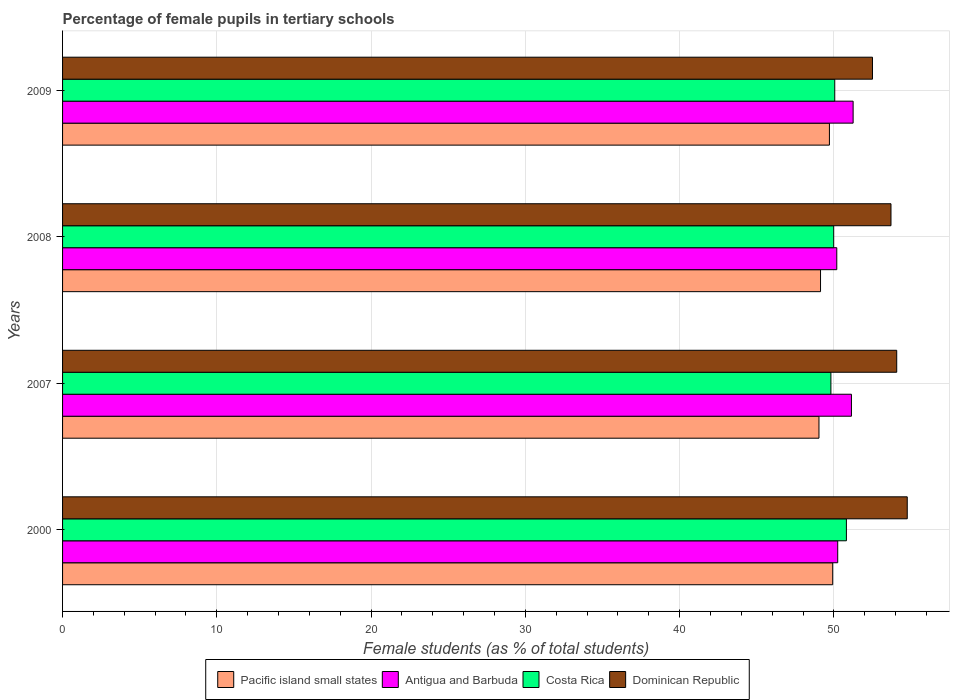How many different coloured bars are there?
Give a very brief answer. 4. Are the number of bars per tick equal to the number of legend labels?
Give a very brief answer. Yes. How many bars are there on the 1st tick from the top?
Your answer should be compact. 4. What is the percentage of female pupils in tertiary schools in Pacific island small states in 2000?
Your response must be concise. 49.92. Across all years, what is the maximum percentage of female pupils in tertiary schools in Dominican Republic?
Your response must be concise. 54.75. Across all years, what is the minimum percentage of female pupils in tertiary schools in Antigua and Barbuda?
Your response must be concise. 50.19. What is the total percentage of female pupils in tertiary schools in Antigua and Barbuda in the graph?
Offer a terse response. 202.81. What is the difference between the percentage of female pupils in tertiary schools in Antigua and Barbuda in 2007 and that in 2008?
Offer a very short reply. 0.95. What is the difference between the percentage of female pupils in tertiary schools in Antigua and Barbuda in 2000 and the percentage of female pupils in tertiary schools in Dominican Republic in 2007?
Provide a short and direct response. -3.82. What is the average percentage of female pupils in tertiary schools in Antigua and Barbuda per year?
Your answer should be compact. 50.7. In the year 2008, what is the difference between the percentage of female pupils in tertiary schools in Costa Rica and percentage of female pupils in tertiary schools in Pacific island small states?
Keep it short and to the point. 0.85. In how many years, is the percentage of female pupils in tertiary schools in Dominican Republic greater than 42 %?
Ensure brevity in your answer.  4. What is the ratio of the percentage of female pupils in tertiary schools in Costa Rica in 2000 to that in 2007?
Make the answer very short. 1.02. Is the difference between the percentage of female pupils in tertiary schools in Costa Rica in 2007 and 2009 greater than the difference between the percentage of female pupils in tertiary schools in Pacific island small states in 2007 and 2009?
Offer a very short reply. Yes. What is the difference between the highest and the second highest percentage of female pupils in tertiary schools in Pacific island small states?
Ensure brevity in your answer.  0.21. What is the difference between the highest and the lowest percentage of female pupils in tertiary schools in Dominican Republic?
Provide a succinct answer. 2.25. In how many years, is the percentage of female pupils in tertiary schools in Antigua and Barbuda greater than the average percentage of female pupils in tertiary schools in Antigua and Barbuda taken over all years?
Provide a short and direct response. 2. Is it the case that in every year, the sum of the percentage of female pupils in tertiary schools in Pacific island small states and percentage of female pupils in tertiary schools in Costa Rica is greater than the sum of percentage of female pupils in tertiary schools in Dominican Republic and percentage of female pupils in tertiary schools in Antigua and Barbuda?
Offer a terse response. Yes. What does the 1st bar from the bottom in 2009 represents?
Give a very brief answer. Pacific island small states. Is it the case that in every year, the sum of the percentage of female pupils in tertiary schools in Dominican Republic and percentage of female pupils in tertiary schools in Pacific island small states is greater than the percentage of female pupils in tertiary schools in Antigua and Barbuda?
Keep it short and to the point. Yes. Are all the bars in the graph horizontal?
Provide a succinct answer. Yes. How many years are there in the graph?
Ensure brevity in your answer.  4. Are the values on the major ticks of X-axis written in scientific E-notation?
Provide a succinct answer. No. Does the graph contain grids?
Ensure brevity in your answer.  Yes. How many legend labels are there?
Ensure brevity in your answer.  4. How are the legend labels stacked?
Provide a short and direct response. Horizontal. What is the title of the graph?
Offer a terse response. Percentage of female pupils in tertiary schools. Does "Togo" appear as one of the legend labels in the graph?
Make the answer very short. No. What is the label or title of the X-axis?
Your answer should be compact. Female students (as % of total students). What is the label or title of the Y-axis?
Give a very brief answer. Years. What is the Female students (as % of total students) in Pacific island small states in 2000?
Provide a succinct answer. 49.92. What is the Female students (as % of total students) of Antigua and Barbuda in 2000?
Offer a terse response. 50.25. What is the Female students (as % of total students) in Costa Rica in 2000?
Give a very brief answer. 50.81. What is the Female students (as % of total students) of Dominican Republic in 2000?
Make the answer very short. 54.75. What is the Female students (as % of total students) in Pacific island small states in 2007?
Keep it short and to the point. 49.03. What is the Female students (as % of total students) in Antigua and Barbuda in 2007?
Offer a terse response. 51.14. What is the Female students (as % of total students) of Costa Rica in 2007?
Offer a terse response. 49.8. What is the Female students (as % of total students) of Dominican Republic in 2007?
Your answer should be very brief. 54.07. What is the Female students (as % of total students) in Pacific island small states in 2008?
Make the answer very short. 49.13. What is the Female students (as % of total students) in Antigua and Barbuda in 2008?
Offer a very short reply. 50.19. What is the Female students (as % of total students) of Costa Rica in 2008?
Make the answer very short. 49.99. What is the Female students (as % of total students) of Dominican Republic in 2008?
Make the answer very short. 53.7. What is the Female students (as % of total students) in Pacific island small states in 2009?
Your response must be concise. 49.71. What is the Female students (as % of total students) of Antigua and Barbuda in 2009?
Ensure brevity in your answer.  51.24. What is the Female students (as % of total students) in Costa Rica in 2009?
Your answer should be compact. 50.05. What is the Female students (as % of total students) of Dominican Republic in 2009?
Your answer should be compact. 52.5. Across all years, what is the maximum Female students (as % of total students) in Pacific island small states?
Offer a terse response. 49.92. Across all years, what is the maximum Female students (as % of total students) of Antigua and Barbuda?
Provide a short and direct response. 51.24. Across all years, what is the maximum Female students (as % of total students) of Costa Rica?
Make the answer very short. 50.81. Across all years, what is the maximum Female students (as % of total students) in Dominican Republic?
Your answer should be very brief. 54.75. Across all years, what is the minimum Female students (as % of total students) of Pacific island small states?
Provide a succinct answer. 49.03. Across all years, what is the minimum Female students (as % of total students) in Antigua and Barbuda?
Make the answer very short. 50.19. Across all years, what is the minimum Female students (as % of total students) in Costa Rica?
Offer a terse response. 49.8. Across all years, what is the minimum Female students (as % of total students) of Dominican Republic?
Ensure brevity in your answer.  52.5. What is the total Female students (as % of total students) in Pacific island small states in the graph?
Give a very brief answer. 197.79. What is the total Female students (as % of total students) in Antigua and Barbuda in the graph?
Offer a very short reply. 202.81. What is the total Female students (as % of total students) in Costa Rica in the graph?
Provide a short and direct response. 200.65. What is the total Female students (as % of total students) in Dominican Republic in the graph?
Your response must be concise. 215.02. What is the difference between the Female students (as % of total students) in Pacific island small states in 2000 and that in 2007?
Give a very brief answer. 0.89. What is the difference between the Female students (as % of total students) of Antigua and Barbuda in 2000 and that in 2007?
Ensure brevity in your answer.  -0.89. What is the difference between the Female students (as % of total students) in Dominican Republic in 2000 and that in 2007?
Your response must be concise. 0.68. What is the difference between the Female students (as % of total students) in Pacific island small states in 2000 and that in 2008?
Your answer should be compact. 0.79. What is the difference between the Female students (as % of total students) in Antigua and Barbuda in 2000 and that in 2008?
Provide a short and direct response. 0.06. What is the difference between the Female students (as % of total students) of Costa Rica in 2000 and that in 2008?
Provide a short and direct response. 0.82. What is the difference between the Female students (as % of total students) in Dominican Republic in 2000 and that in 2008?
Ensure brevity in your answer.  1.05. What is the difference between the Female students (as % of total students) of Pacific island small states in 2000 and that in 2009?
Ensure brevity in your answer.  0.21. What is the difference between the Female students (as % of total students) of Antigua and Barbuda in 2000 and that in 2009?
Ensure brevity in your answer.  -1. What is the difference between the Female students (as % of total students) in Costa Rica in 2000 and that in 2009?
Your response must be concise. 0.75. What is the difference between the Female students (as % of total students) in Dominican Republic in 2000 and that in 2009?
Your answer should be very brief. 2.25. What is the difference between the Female students (as % of total students) of Pacific island small states in 2007 and that in 2008?
Your response must be concise. -0.1. What is the difference between the Female students (as % of total students) of Antigua and Barbuda in 2007 and that in 2008?
Make the answer very short. 0.95. What is the difference between the Female students (as % of total students) in Costa Rica in 2007 and that in 2008?
Your answer should be compact. -0.18. What is the difference between the Female students (as % of total students) in Dominican Republic in 2007 and that in 2008?
Provide a short and direct response. 0.37. What is the difference between the Female students (as % of total students) in Pacific island small states in 2007 and that in 2009?
Your answer should be compact. -0.68. What is the difference between the Female students (as % of total students) in Antigua and Barbuda in 2007 and that in 2009?
Give a very brief answer. -0.11. What is the difference between the Female students (as % of total students) in Costa Rica in 2007 and that in 2009?
Your answer should be very brief. -0.25. What is the difference between the Female students (as % of total students) of Dominican Republic in 2007 and that in 2009?
Provide a short and direct response. 1.57. What is the difference between the Female students (as % of total students) in Pacific island small states in 2008 and that in 2009?
Provide a short and direct response. -0.58. What is the difference between the Female students (as % of total students) of Antigua and Barbuda in 2008 and that in 2009?
Give a very brief answer. -1.06. What is the difference between the Female students (as % of total students) in Costa Rica in 2008 and that in 2009?
Keep it short and to the point. -0.07. What is the difference between the Female students (as % of total students) in Dominican Republic in 2008 and that in 2009?
Provide a succinct answer. 1.2. What is the difference between the Female students (as % of total students) of Pacific island small states in 2000 and the Female students (as % of total students) of Antigua and Barbuda in 2007?
Your response must be concise. -1.21. What is the difference between the Female students (as % of total students) in Pacific island small states in 2000 and the Female students (as % of total students) in Costa Rica in 2007?
Offer a terse response. 0.12. What is the difference between the Female students (as % of total students) in Pacific island small states in 2000 and the Female students (as % of total students) in Dominican Republic in 2007?
Keep it short and to the point. -4.15. What is the difference between the Female students (as % of total students) of Antigua and Barbuda in 2000 and the Female students (as % of total students) of Costa Rica in 2007?
Your answer should be very brief. 0.44. What is the difference between the Female students (as % of total students) of Antigua and Barbuda in 2000 and the Female students (as % of total students) of Dominican Republic in 2007?
Offer a very short reply. -3.82. What is the difference between the Female students (as % of total students) in Costa Rica in 2000 and the Female students (as % of total students) in Dominican Republic in 2007?
Offer a very short reply. -3.26. What is the difference between the Female students (as % of total students) of Pacific island small states in 2000 and the Female students (as % of total students) of Antigua and Barbuda in 2008?
Give a very brief answer. -0.26. What is the difference between the Female students (as % of total students) in Pacific island small states in 2000 and the Female students (as % of total students) in Costa Rica in 2008?
Provide a short and direct response. -0.07. What is the difference between the Female students (as % of total students) in Pacific island small states in 2000 and the Female students (as % of total students) in Dominican Republic in 2008?
Offer a terse response. -3.78. What is the difference between the Female students (as % of total students) in Antigua and Barbuda in 2000 and the Female students (as % of total students) in Costa Rica in 2008?
Make the answer very short. 0.26. What is the difference between the Female students (as % of total students) of Antigua and Barbuda in 2000 and the Female students (as % of total students) of Dominican Republic in 2008?
Your answer should be compact. -3.45. What is the difference between the Female students (as % of total students) in Costa Rica in 2000 and the Female students (as % of total students) in Dominican Republic in 2008?
Give a very brief answer. -2.89. What is the difference between the Female students (as % of total students) of Pacific island small states in 2000 and the Female students (as % of total students) of Antigua and Barbuda in 2009?
Keep it short and to the point. -1.32. What is the difference between the Female students (as % of total students) in Pacific island small states in 2000 and the Female students (as % of total students) in Costa Rica in 2009?
Provide a succinct answer. -0.13. What is the difference between the Female students (as % of total students) in Pacific island small states in 2000 and the Female students (as % of total students) in Dominican Republic in 2009?
Keep it short and to the point. -2.58. What is the difference between the Female students (as % of total students) in Antigua and Barbuda in 2000 and the Female students (as % of total students) in Costa Rica in 2009?
Your answer should be very brief. 0.19. What is the difference between the Female students (as % of total students) in Antigua and Barbuda in 2000 and the Female students (as % of total students) in Dominican Republic in 2009?
Make the answer very short. -2.25. What is the difference between the Female students (as % of total students) in Costa Rica in 2000 and the Female students (as % of total students) in Dominican Republic in 2009?
Your response must be concise. -1.69. What is the difference between the Female students (as % of total students) of Pacific island small states in 2007 and the Female students (as % of total students) of Antigua and Barbuda in 2008?
Provide a short and direct response. -1.15. What is the difference between the Female students (as % of total students) of Pacific island small states in 2007 and the Female students (as % of total students) of Costa Rica in 2008?
Your answer should be compact. -0.96. What is the difference between the Female students (as % of total students) of Pacific island small states in 2007 and the Female students (as % of total students) of Dominican Republic in 2008?
Give a very brief answer. -4.67. What is the difference between the Female students (as % of total students) of Antigua and Barbuda in 2007 and the Female students (as % of total students) of Costa Rica in 2008?
Your answer should be very brief. 1.15. What is the difference between the Female students (as % of total students) of Antigua and Barbuda in 2007 and the Female students (as % of total students) of Dominican Republic in 2008?
Your response must be concise. -2.56. What is the difference between the Female students (as % of total students) of Costa Rica in 2007 and the Female students (as % of total students) of Dominican Republic in 2008?
Your answer should be very brief. -3.89. What is the difference between the Female students (as % of total students) of Pacific island small states in 2007 and the Female students (as % of total students) of Antigua and Barbuda in 2009?
Give a very brief answer. -2.21. What is the difference between the Female students (as % of total students) in Pacific island small states in 2007 and the Female students (as % of total students) in Costa Rica in 2009?
Offer a terse response. -1.02. What is the difference between the Female students (as % of total students) of Pacific island small states in 2007 and the Female students (as % of total students) of Dominican Republic in 2009?
Make the answer very short. -3.47. What is the difference between the Female students (as % of total students) in Antigua and Barbuda in 2007 and the Female students (as % of total students) in Costa Rica in 2009?
Give a very brief answer. 1.08. What is the difference between the Female students (as % of total students) in Antigua and Barbuda in 2007 and the Female students (as % of total students) in Dominican Republic in 2009?
Provide a succinct answer. -1.36. What is the difference between the Female students (as % of total students) in Costa Rica in 2007 and the Female students (as % of total students) in Dominican Republic in 2009?
Provide a succinct answer. -2.7. What is the difference between the Female students (as % of total students) of Pacific island small states in 2008 and the Female students (as % of total students) of Antigua and Barbuda in 2009?
Make the answer very short. -2.11. What is the difference between the Female students (as % of total students) of Pacific island small states in 2008 and the Female students (as % of total students) of Costa Rica in 2009?
Offer a very short reply. -0.92. What is the difference between the Female students (as % of total students) in Pacific island small states in 2008 and the Female students (as % of total students) in Dominican Republic in 2009?
Ensure brevity in your answer.  -3.37. What is the difference between the Female students (as % of total students) in Antigua and Barbuda in 2008 and the Female students (as % of total students) in Costa Rica in 2009?
Provide a short and direct response. 0.13. What is the difference between the Female students (as % of total students) in Antigua and Barbuda in 2008 and the Female students (as % of total students) in Dominican Republic in 2009?
Your response must be concise. -2.31. What is the difference between the Female students (as % of total students) in Costa Rica in 2008 and the Female students (as % of total students) in Dominican Republic in 2009?
Keep it short and to the point. -2.51. What is the average Female students (as % of total students) in Pacific island small states per year?
Provide a short and direct response. 49.45. What is the average Female students (as % of total students) of Antigua and Barbuda per year?
Provide a short and direct response. 50.7. What is the average Female students (as % of total students) in Costa Rica per year?
Make the answer very short. 50.16. What is the average Female students (as % of total students) in Dominican Republic per year?
Offer a terse response. 53.76. In the year 2000, what is the difference between the Female students (as % of total students) in Pacific island small states and Female students (as % of total students) in Antigua and Barbuda?
Make the answer very short. -0.33. In the year 2000, what is the difference between the Female students (as % of total students) in Pacific island small states and Female students (as % of total students) in Costa Rica?
Give a very brief answer. -0.89. In the year 2000, what is the difference between the Female students (as % of total students) of Pacific island small states and Female students (as % of total students) of Dominican Republic?
Your answer should be compact. -4.83. In the year 2000, what is the difference between the Female students (as % of total students) of Antigua and Barbuda and Female students (as % of total students) of Costa Rica?
Provide a succinct answer. -0.56. In the year 2000, what is the difference between the Female students (as % of total students) in Antigua and Barbuda and Female students (as % of total students) in Dominican Republic?
Your response must be concise. -4.51. In the year 2000, what is the difference between the Female students (as % of total students) of Costa Rica and Female students (as % of total students) of Dominican Republic?
Your answer should be very brief. -3.94. In the year 2007, what is the difference between the Female students (as % of total students) in Pacific island small states and Female students (as % of total students) in Antigua and Barbuda?
Your response must be concise. -2.1. In the year 2007, what is the difference between the Female students (as % of total students) in Pacific island small states and Female students (as % of total students) in Costa Rica?
Provide a succinct answer. -0.77. In the year 2007, what is the difference between the Female students (as % of total students) of Pacific island small states and Female students (as % of total students) of Dominican Republic?
Provide a succinct answer. -5.04. In the year 2007, what is the difference between the Female students (as % of total students) of Antigua and Barbuda and Female students (as % of total students) of Costa Rica?
Your response must be concise. 1.33. In the year 2007, what is the difference between the Female students (as % of total students) in Antigua and Barbuda and Female students (as % of total students) in Dominican Republic?
Offer a terse response. -2.94. In the year 2007, what is the difference between the Female students (as % of total students) of Costa Rica and Female students (as % of total students) of Dominican Republic?
Provide a short and direct response. -4.27. In the year 2008, what is the difference between the Female students (as % of total students) of Pacific island small states and Female students (as % of total students) of Antigua and Barbuda?
Keep it short and to the point. -1.05. In the year 2008, what is the difference between the Female students (as % of total students) in Pacific island small states and Female students (as % of total students) in Costa Rica?
Offer a terse response. -0.85. In the year 2008, what is the difference between the Female students (as % of total students) of Pacific island small states and Female students (as % of total students) of Dominican Republic?
Offer a terse response. -4.57. In the year 2008, what is the difference between the Female students (as % of total students) of Antigua and Barbuda and Female students (as % of total students) of Costa Rica?
Offer a terse response. 0.2. In the year 2008, what is the difference between the Female students (as % of total students) in Antigua and Barbuda and Female students (as % of total students) in Dominican Republic?
Give a very brief answer. -3.51. In the year 2008, what is the difference between the Female students (as % of total students) in Costa Rica and Female students (as % of total students) in Dominican Republic?
Offer a terse response. -3.71. In the year 2009, what is the difference between the Female students (as % of total students) in Pacific island small states and Female students (as % of total students) in Antigua and Barbuda?
Offer a terse response. -1.54. In the year 2009, what is the difference between the Female students (as % of total students) in Pacific island small states and Female students (as % of total students) in Costa Rica?
Ensure brevity in your answer.  -0.35. In the year 2009, what is the difference between the Female students (as % of total students) of Pacific island small states and Female students (as % of total students) of Dominican Republic?
Offer a very short reply. -2.79. In the year 2009, what is the difference between the Female students (as % of total students) in Antigua and Barbuda and Female students (as % of total students) in Costa Rica?
Offer a very short reply. 1.19. In the year 2009, what is the difference between the Female students (as % of total students) of Antigua and Barbuda and Female students (as % of total students) of Dominican Republic?
Provide a succinct answer. -1.26. In the year 2009, what is the difference between the Female students (as % of total students) in Costa Rica and Female students (as % of total students) in Dominican Republic?
Offer a terse response. -2.45. What is the ratio of the Female students (as % of total students) in Pacific island small states in 2000 to that in 2007?
Offer a terse response. 1.02. What is the ratio of the Female students (as % of total students) of Antigua and Barbuda in 2000 to that in 2007?
Your response must be concise. 0.98. What is the ratio of the Female students (as % of total students) in Costa Rica in 2000 to that in 2007?
Provide a short and direct response. 1.02. What is the ratio of the Female students (as % of total students) in Dominican Republic in 2000 to that in 2007?
Your response must be concise. 1.01. What is the ratio of the Female students (as % of total students) in Pacific island small states in 2000 to that in 2008?
Provide a short and direct response. 1.02. What is the ratio of the Female students (as % of total students) in Antigua and Barbuda in 2000 to that in 2008?
Your response must be concise. 1. What is the ratio of the Female students (as % of total students) of Costa Rica in 2000 to that in 2008?
Ensure brevity in your answer.  1.02. What is the ratio of the Female students (as % of total students) of Dominican Republic in 2000 to that in 2008?
Provide a short and direct response. 1.02. What is the ratio of the Female students (as % of total students) of Antigua and Barbuda in 2000 to that in 2009?
Keep it short and to the point. 0.98. What is the ratio of the Female students (as % of total students) of Costa Rica in 2000 to that in 2009?
Your response must be concise. 1.02. What is the ratio of the Female students (as % of total students) in Dominican Republic in 2000 to that in 2009?
Your response must be concise. 1.04. What is the ratio of the Female students (as % of total students) of Antigua and Barbuda in 2007 to that in 2008?
Provide a short and direct response. 1.02. What is the ratio of the Female students (as % of total students) in Dominican Republic in 2007 to that in 2008?
Your response must be concise. 1.01. What is the ratio of the Female students (as % of total students) in Pacific island small states in 2007 to that in 2009?
Give a very brief answer. 0.99. What is the ratio of the Female students (as % of total students) in Antigua and Barbuda in 2007 to that in 2009?
Provide a succinct answer. 1. What is the ratio of the Female students (as % of total students) in Costa Rica in 2007 to that in 2009?
Your answer should be very brief. 0.99. What is the ratio of the Female students (as % of total students) of Dominican Republic in 2007 to that in 2009?
Ensure brevity in your answer.  1.03. What is the ratio of the Female students (as % of total students) in Pacific island small states in 2008 to that in 2009?
Make the answer very short. 0.99. What is the ratio of the Female students (as % of total students) in Antigua and Barbuda in 2008 to that in 2009?
Keep it short and to the point. 0.98. What is the ratio of the Female students (as % of total students) of Dominican Republic in 2008 to that in 2009?
Your response must be concise. 1.02. What is the difference between the highest and the second highest Female students (as % of total students) in Pacific island small states?
Give a very brief answer. 0.21. What is the difference between the highest and the second highest Female students (as % of total students) in Antigua and Barbuda?
Provide a short and direct response. 0.11. What is the difference between the highest and the second highest Female students (as % of total students) in Costa Rica?
Offer a very short reply. 0.75. What is the difference between the highest and the second highest Female students (as % of total students) of Dominican Republic?
Ensure brevity in your answer.  0.68. What is the difference between the highest and the lowest Female students (as % of total students) in Pacific island small states?
Give a very brief answer. 0.89. What is the difference between the highest and the lowest Female students (as % of total students) in Antigua and Barbuda?
Keep it short and to the point. 1.06. What is the difference between the highest and the lowest Female students (as % of total students) in Costa Rica?
Your answer should be compact. 1. What is the difference between the highest and the lowest Female students (as % of total students) of Dominican Republic?
Offer a terse response. 2.25. 